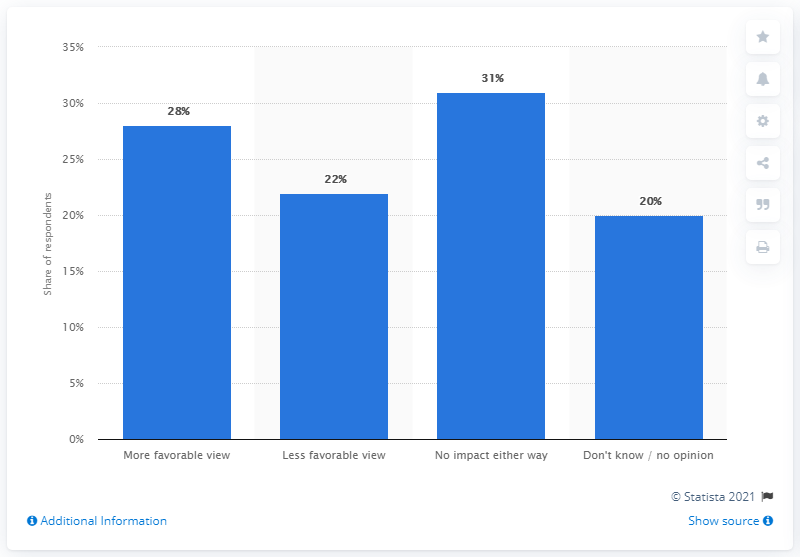Indicate a few pertinent items in this graphic. According to a survey, 28% of adults in the United States said that they had a more favorable view of brands that publicly expressed their support for the police on social media. 